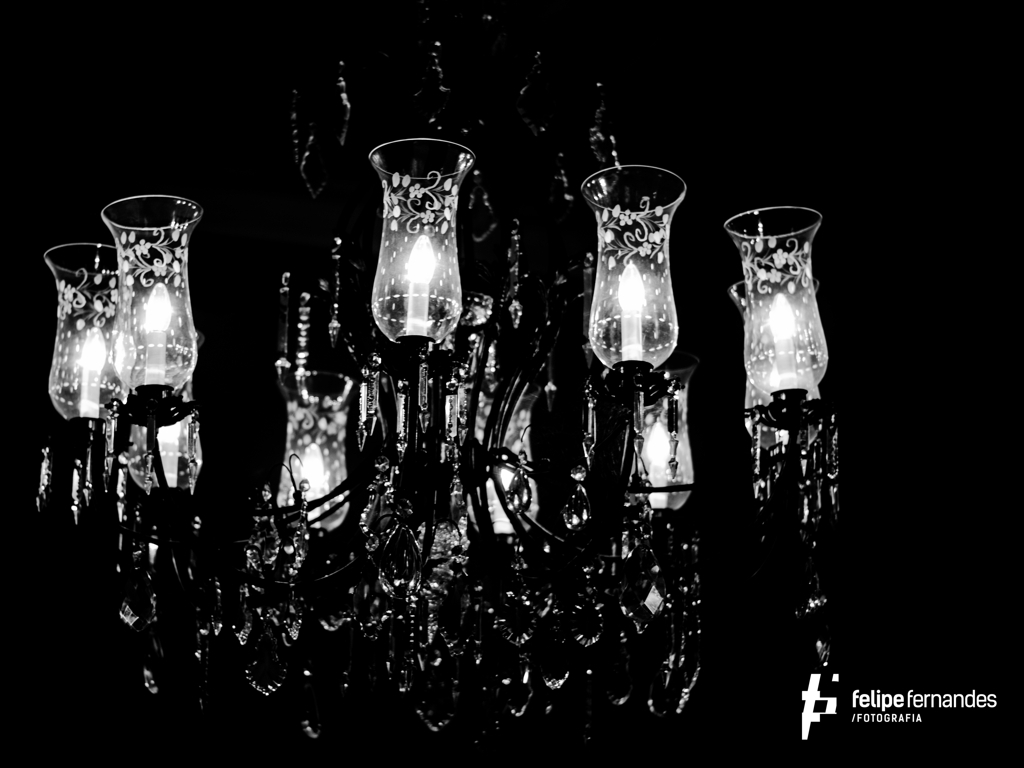What style or period does the chandelier represent? The chandelier is reminiscent of Baroque design with its ornate detailing and curving forms, suggesting a sense of grandeur and opulence typical from the 17th and 18th centuries. Its sophisticated appearance makes it a timeless piece that can enhance the decor of a contemporary space as well. 